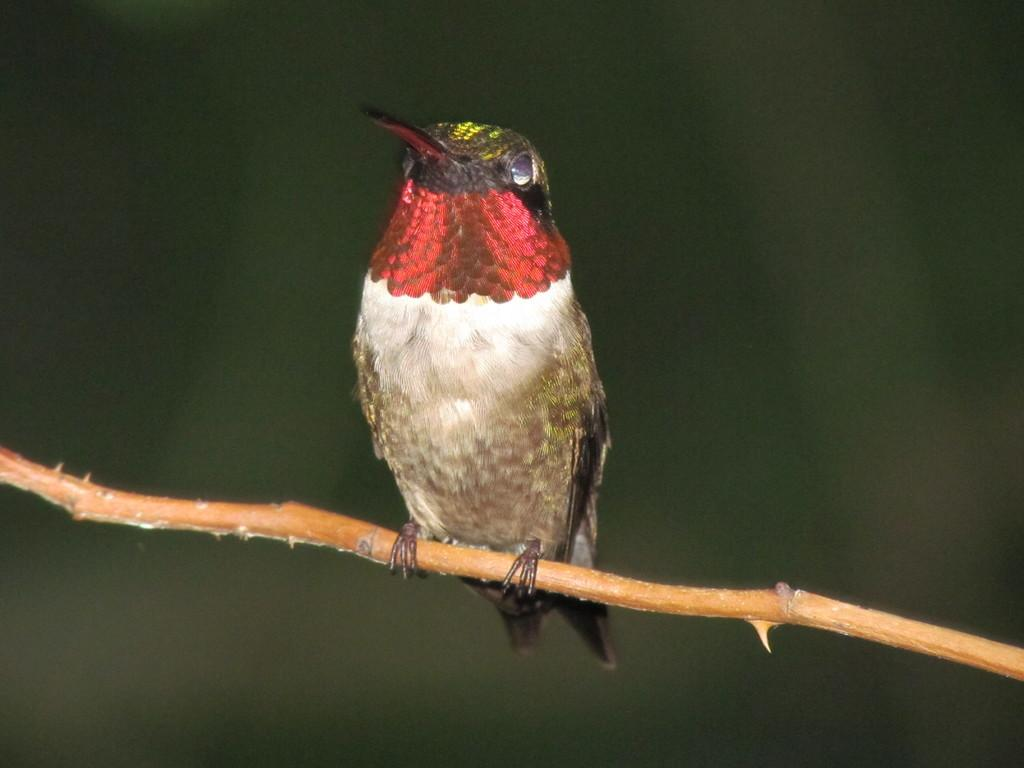What type of animal can be seen in the image? There is a bird in the image. Where is the bird located in the image? The bird is on the branch of a tree. What type of bells can be heard ringing in the image? There are no bells present in the image, and therefore no sounds can be heard. 